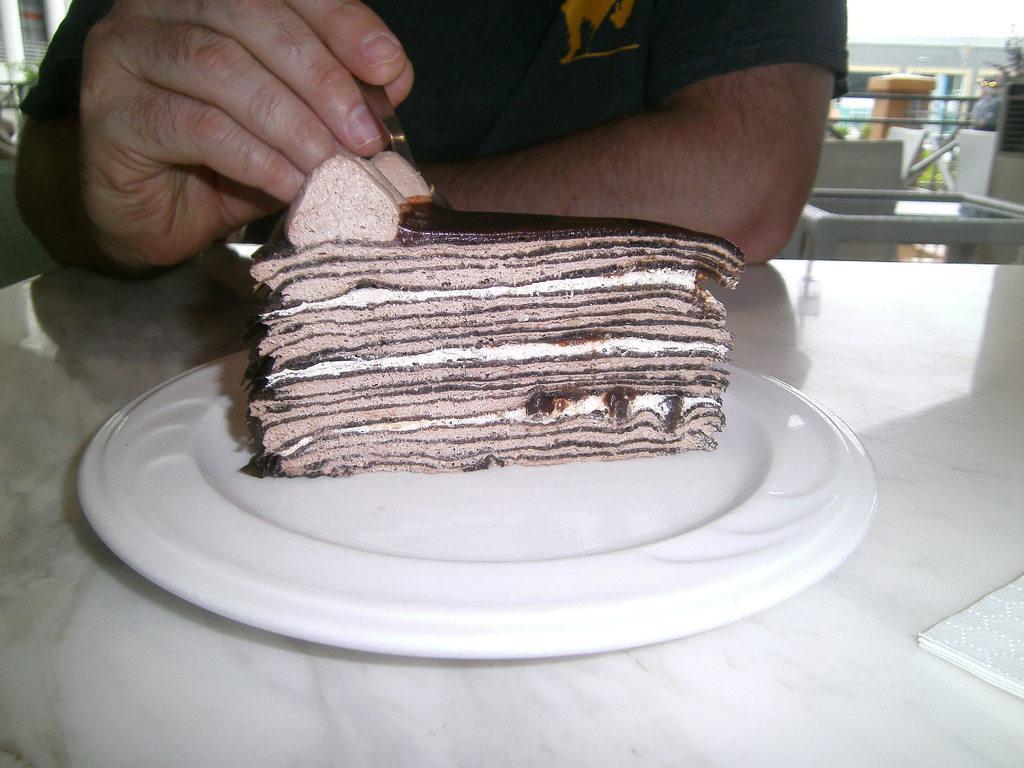Please provide a concise description of this image. In this image we can see cake piece in a plate and tissue papers on a table. In the background we can see a person holding a spoon in the hand, glass table, pillars and objects. 